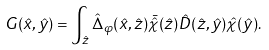<formula> <loc_0><loc_0><loc_500><loc_500>G ( \hat { x } , \hat { y } ) = \int _ { \hat { z } } \hat { \Delta } _ { \varphi } ( \hat { x } , \hat { z } ) \bar { \hat { \chi } } ( \hat { z } ) \hat { D } ( \hat { z } , \hat { y } ) \hat { \chi } ( \hat { y } ) .</formula> 